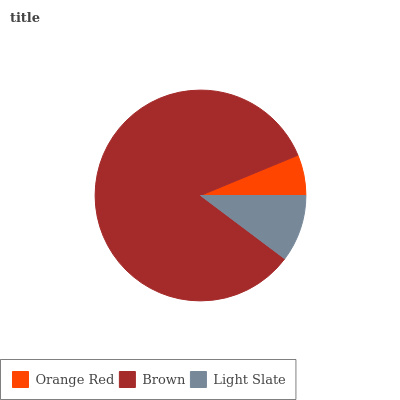Is Orange Red the minimum?
Answer yes or no. Yes. Is Brown the maximum?
Answer yes or no. Yes. Is Light Slate the minimum?
Answer yes or no. No. Is Light Slate the maximum?
Answer yes or no. No. Is Brown greater than Light Slate?
Answer yes or no. Yes. Is Light Slate less than Brown?
Answer yes or no. Yes. Is Light Slate greater than Brown?
Answer yes or no. No. Is Brown less than Light Slate?
Answer yes or no. No. Is Light Slate the high median?
Answer yes or no. Yes. Is Light Slate the low median?
Answer yes or no. Yes. Is Brown the high median?
Answer yes or no. No. Is Orange Red the low median?
Answer yes or no. No. 